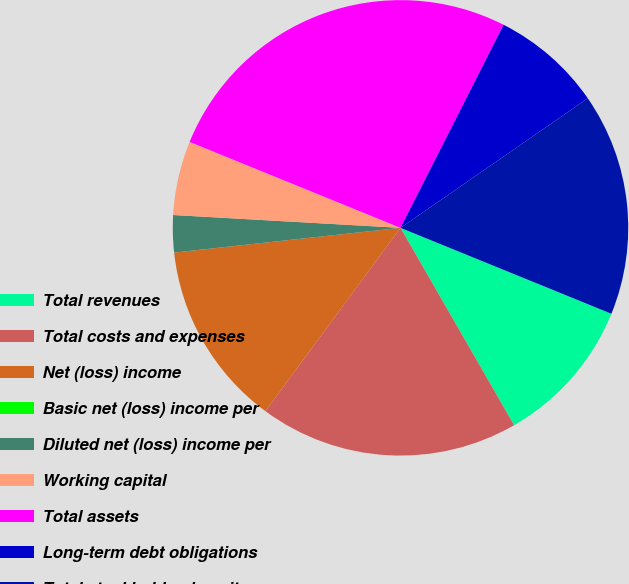Convert chart. <chart><loc_0><loc_0><loc_500><loc_500><pie_chart><fcel>Total revenues<fcel>Total costs and expenses<fcel>Net (loss) income<fcel>Basic net (loss) income per<fcel>Diluted net (loss) income per<fcel>Working capital<fcel>Total assets<fcel>Long-term debt obligations<fcel>Total stockholders' equity<nl><fcel>10.53%<fcel>18.42%<fcel>13.16%<fcel>0.0%<fcel>2.63%<fcel>5.26%<fcel>26.32%<fcel>7.89%<fcel>15.79%<nl></chart> 